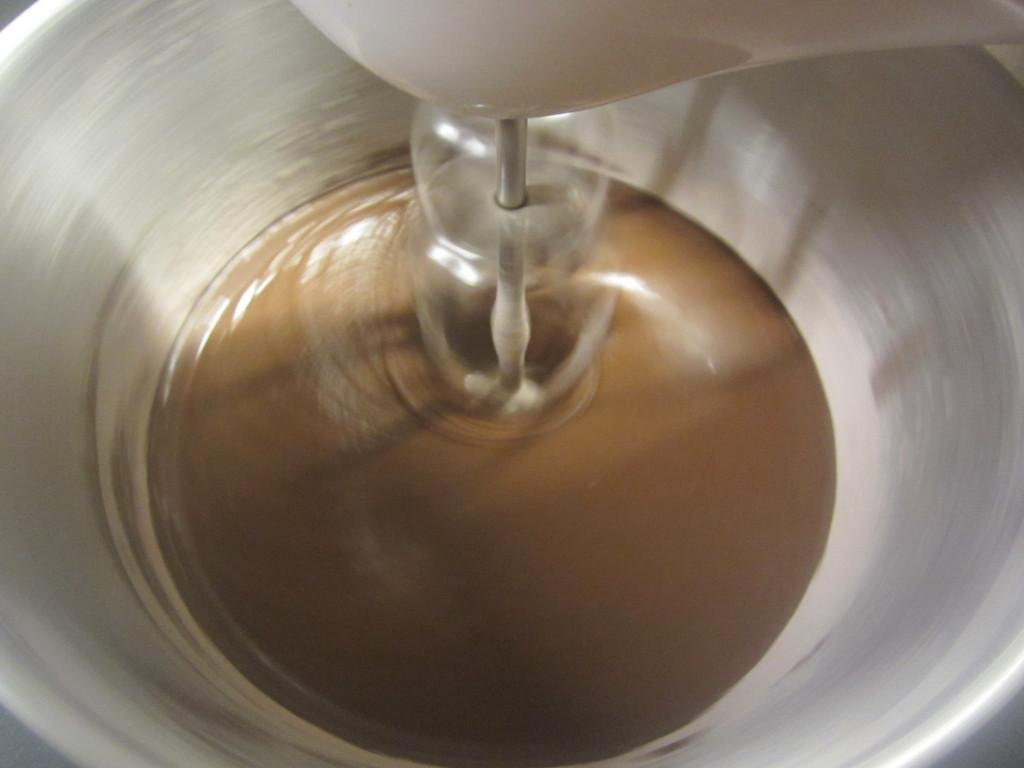What is in the bowl that is visible in the image? There is a bowl with liquid in the image. What other item can be seen in the image? There is a beater in the image. What type of beef is being prepared in the image? There is no beef present in the image; it only features a bowl with liquid and a beater. How does the earthquake affect the bowl and beater in the image? There is no earthquake present in the image, so its effects cannot be observed. 